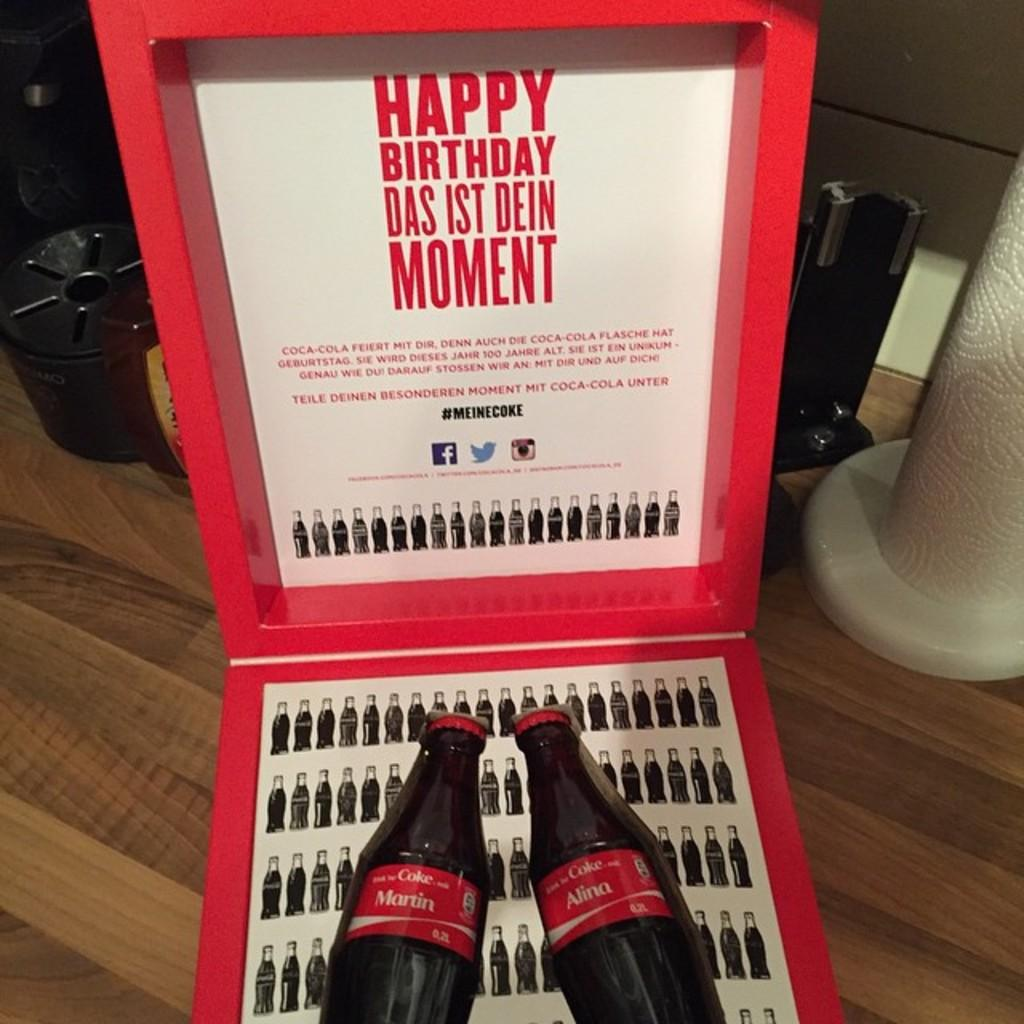What is the main object in the image? There is a box in the image. Where is the box located? The box is placed on a table. What is inside the box? There are two bottles in the box. Can you describe the background of the image? There are objects in the background of the image. What type of jam is being spread on the ball in the image? There is no ball or jam present in the image; it only features a box with two bottles on a table and objects in the background. 